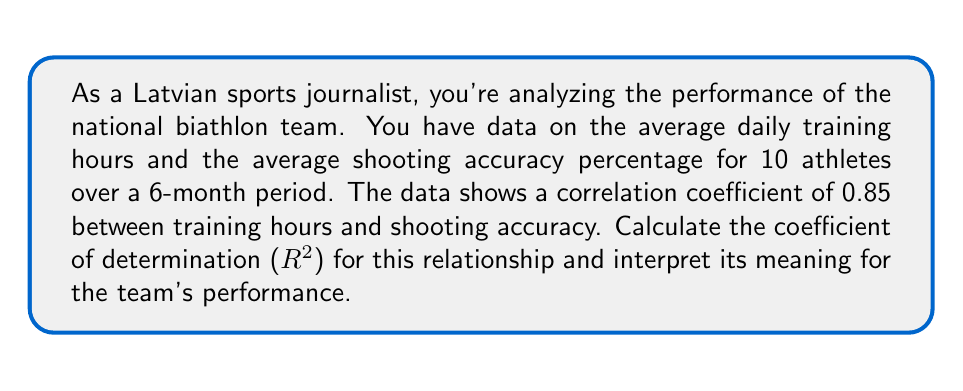Help me with this question. Let's approach this step-by-step:

1) The correlation coefficient (r) is given as 0.85.

2) The coefficient of determination (R-squared) is the square of the correlation coefficient.

3) To calculate R-squared:
   
   $$ R^2 = r^2 = (0.85)^2 = 0.7225 $$

4) To convert to a percentage, multiply by 100:
   
   $$ 0.7225 \times 100 = 72.25\% $$

5) Interpretation:
   The R-squared value of 0.7225 (or 72.25%) indicates that approximately 72.25% of the variability in shooting accuracy can be explained by the variation in training hours.

6) For the Latvian biathlon team, this means:
   - There's a strong positive relationship between training hours and shooting accuracy.
   - About 72.25% of the improvements in shooting accuracy can be attributed to increased training hours.
   - However, about 27.75% of the variation in shooting accuracy is due to other factors not accounted for in this analysis (e.g., equipment quality, weather conditions, individual athlete characteristics).

This information is valuable for optimizing the team's training regimen and potentially improving Latvia's performance in international biathlon competitions.
Answer: $R^2 = 0.7225$ or 72.25% 